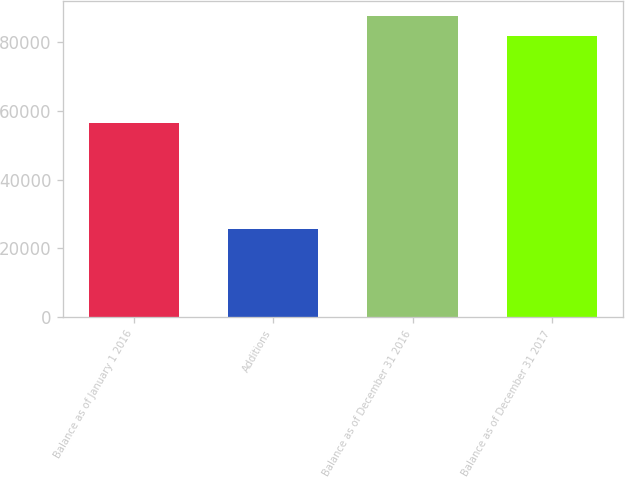Convert chart to OTSL. <chart><loc_0><loc_0><loc_500><loc_500><bar_chart><fcel>Balance as of January 1 2016<fcel>Additions<fcel>Balance as of December 31 2016<fcel>Balance as of December 31 2017<nl><fcel>56499<fcel>25609<fcel>87638.1<fcel>81989<nl></chart> 